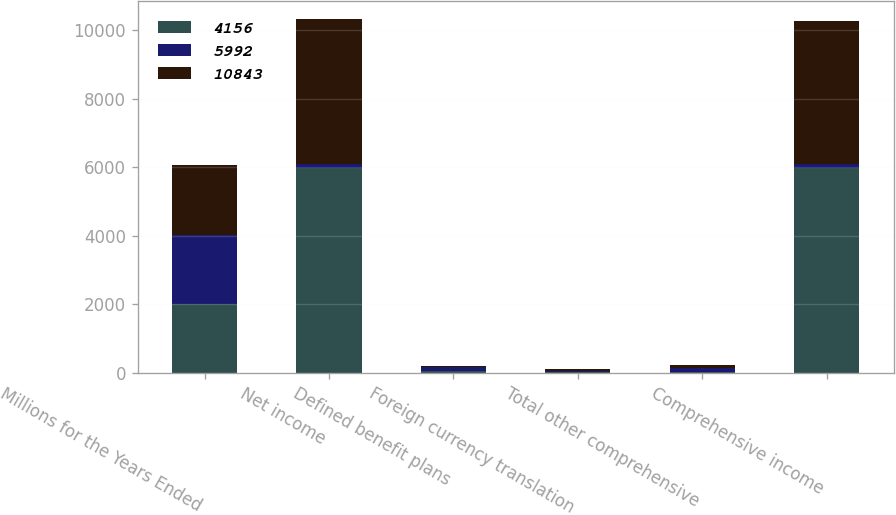Convert chart to OTSL. <chart><loc_0><loc_0><loc_500><loc_500><stacked_bar_chart><ecel><fcel>Millions for the Years Ended<fcel>Net income<fcel>Defined benefit plans<fcel>Foreign currency translation<fcel>Total other comprehensive<fcel>Comprehensive income<nl><fcel>4156<fcel>2018<fcel>5966<fcel>62<fcel>36<fcel>26<fcel>5992<nl><fcel>5992<fcel>2017<fcel>117<fcel>103<fcel>28<fcel>131<fcel>117<nl><fcel>10843<fcel>2016<fcel>4233<fcel>29<fcel>48<fcel>77<fcel>4156<nl></chart> 